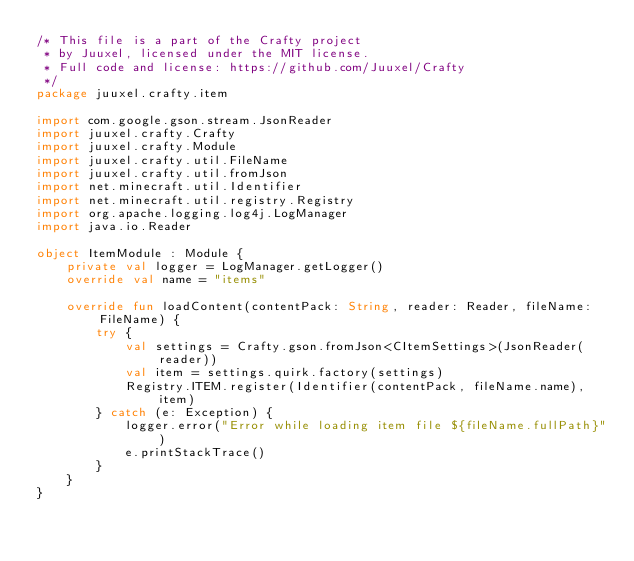Convert code to text. <code><loc_0><loc_0><loc_500><loc_500><_Kotlin_>/* This file is a part of the Crafty project
 * by Juuxel, licensed under the MIT license.
 * Full code and license: https://github.com/Juuxel/Crafty
 */
package juuxel.crafty.item

import com.google.gson.stream.JsonReader
import juuxel.crafty.Crafty
import juuxel.crafty.Module
import juuxel.crafty.util.FileName
import juuxel.crafty.util.fromJson
import net.minecraft.util.Identifier
import net.minecraft.util.registry.Registry
import org.apache.logging.log4j.LogManager
import java.io.Reader

object ItemModule : Module {
    private val logger = LogManager.getLogger()
    override val name = "items"

    override fun loadContent(contentPack: String, reader: Reader, fileName: FileName) {
        try {
            val settings = Crafty.gson.fromJson<CItemSettings>(JsonReader(reader))
            val item = settings.quirk.factory(settings)
            Registry.ITEM.register(Identifier(contentPack, fileName.name), item)
        } catch (e: Exception) {
            logger.error("Error while loading item file ${fileName.fullPath}")
            e.printStackTrace()
        }
    }
}
</code> 